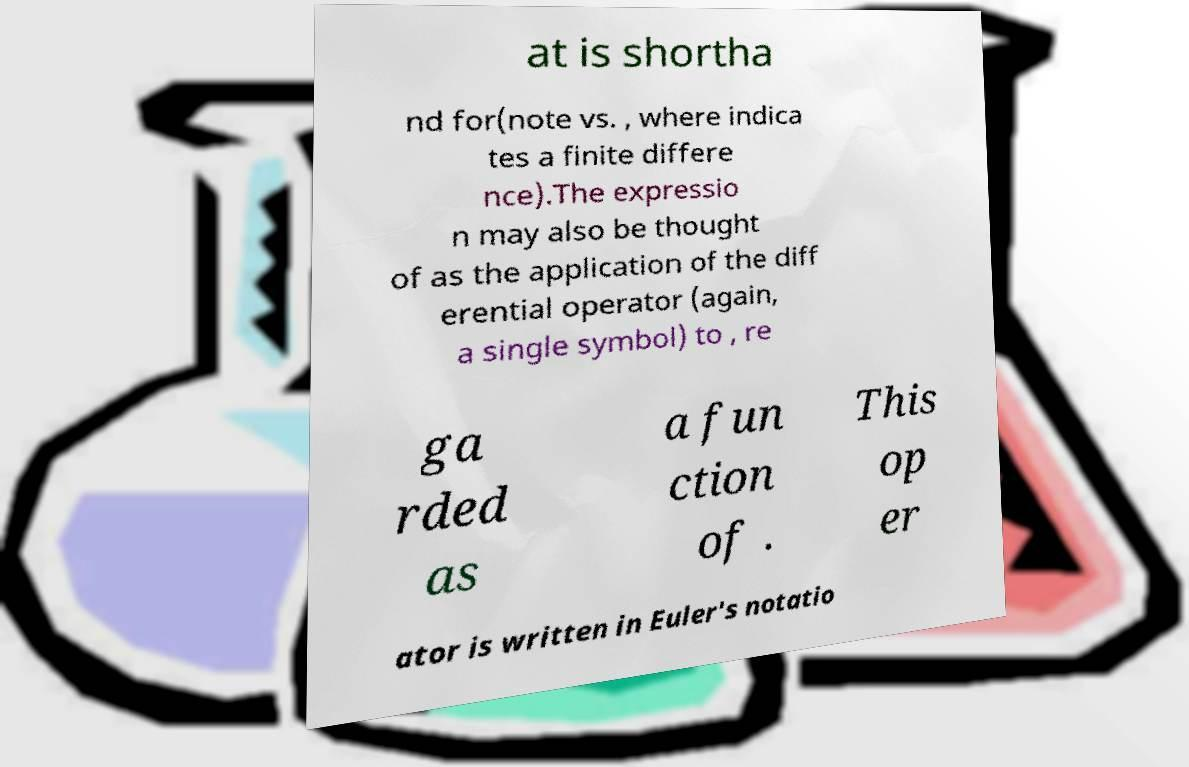Please read and relay the text visible in this image. What does it say? at is shortha nd for(note vs. , where indica tes a finite differe nce).The expressio n may also be thought of as the application of the diff erential operator (again, a single symbol) to , re ga rded as a fun ction of . This op er ator is written in Euler's notatio 